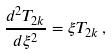Convert formula to latex. <formula><loc_0><loc_0><loc_500><loc_500>\frac { d ^ { 2 } T _ { 2 k } } { d \xi ^ { 2 } } = \xi T _ { 2 k } \, ,</formula> 